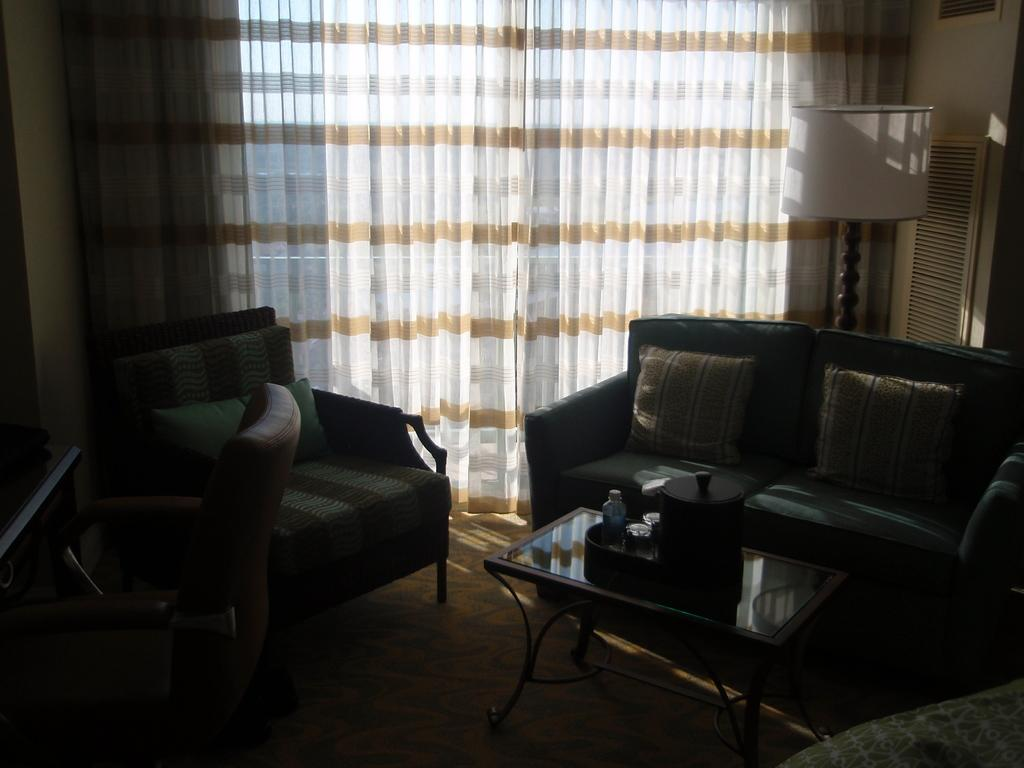What type of furniture is present in the room? There is a sofa, cushions, a chair, and a wooden table in the room. What might be used for seating on the sofa or chair? Cushions are present in the room for seating comfort. What is the purpose of the wooden table in the room? The wooden table is likely used for placing items, as there are items placed on it. Where is the lamp located in the room? The lamp is on the right side of the room. What can be seen in the background of the room? There is a curtain in the background of the room. What is visible at the bottom of the room? There is a floor visible at the bottom of the room. What type of ray is swimming in the room? There is no ray present in the room; it is an indoor space with furniture and decor. 